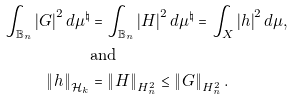<formula> <loc_0><loc_0><loc_500><loc_500>\int _ { \mathbb { B } _ { n } } \left | G \right | ^ { 2 } d \mu ^ { \natural } & = \int _ { \mathbb { B } _ { n } } \left | H \right | ^ { 2 } d \mu ^ { \natural } = \int _ { X } \left | h \right | ^ { 2 } d \mu , \\ & \text {and} \\ \left \| h \right \| _ { \mathcal { H } _ { k } } & = \left \| H \right \| _ { H _ { n } ^ { 2 } } \leq \left \| G \right \| _ { H _ { n } ^ { 2 } } .</formula> 